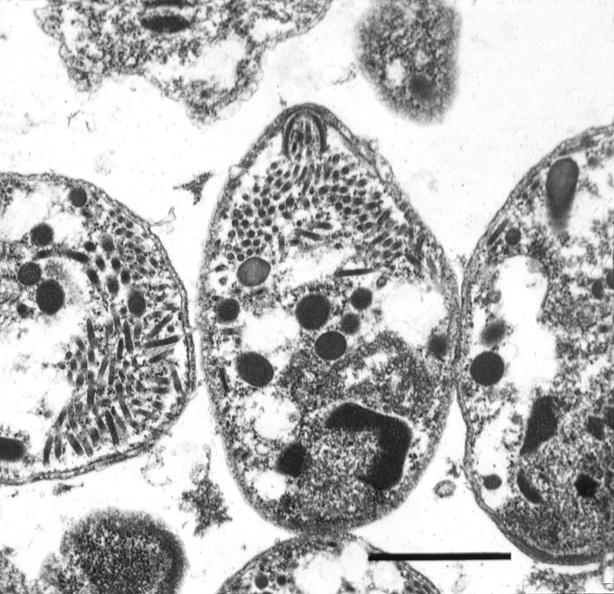what does this image show?
Answer the question using a single word or phrase. Brain 